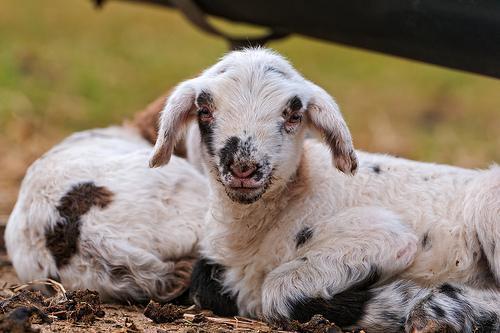How many animals are there?
Give a very brief answer. 2. 